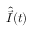Convert formula to latex. <formula><loc_0><loc_0><loc_500><loc_500>\hat { \vec { I } } ( t )</formula> 